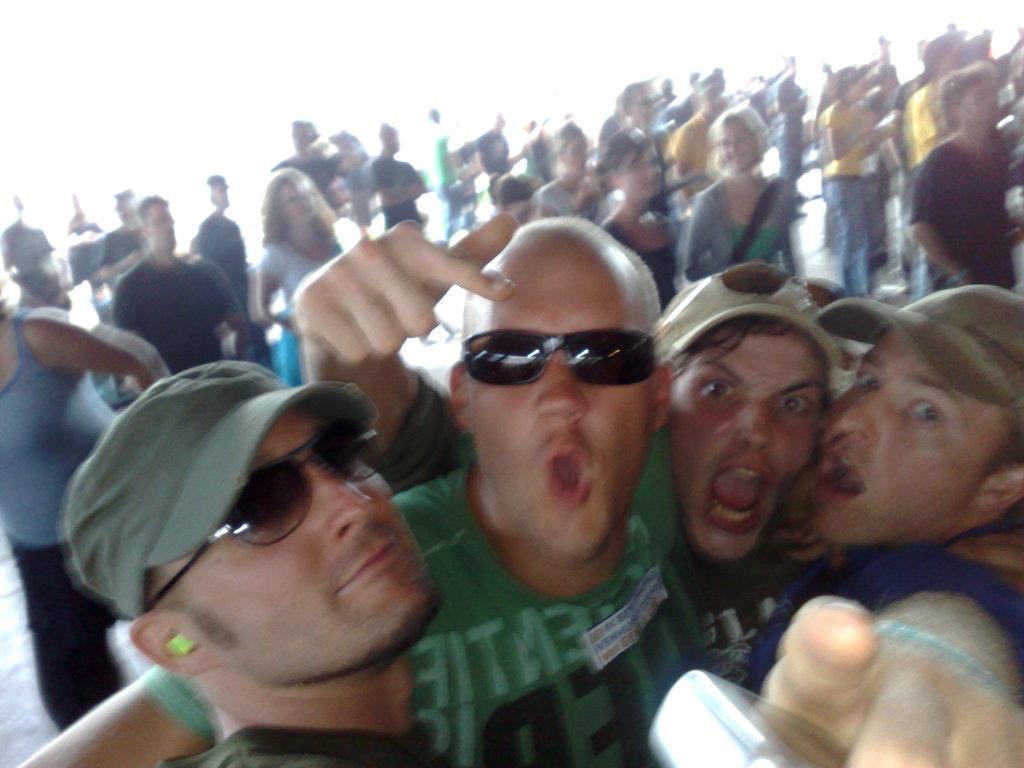In one or two sentences, can you explain what this image depicts? In this image we can see many people standing. 